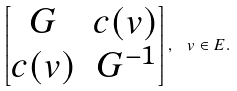<formula> <loc_0><loc_0><loc_500><loc_500>\left [ \begin{matrix} G & c ( v ) \\ c ( v ) & G ^ { - 1 } \end{matrix} \right ] , \ v \in E .</formula> 